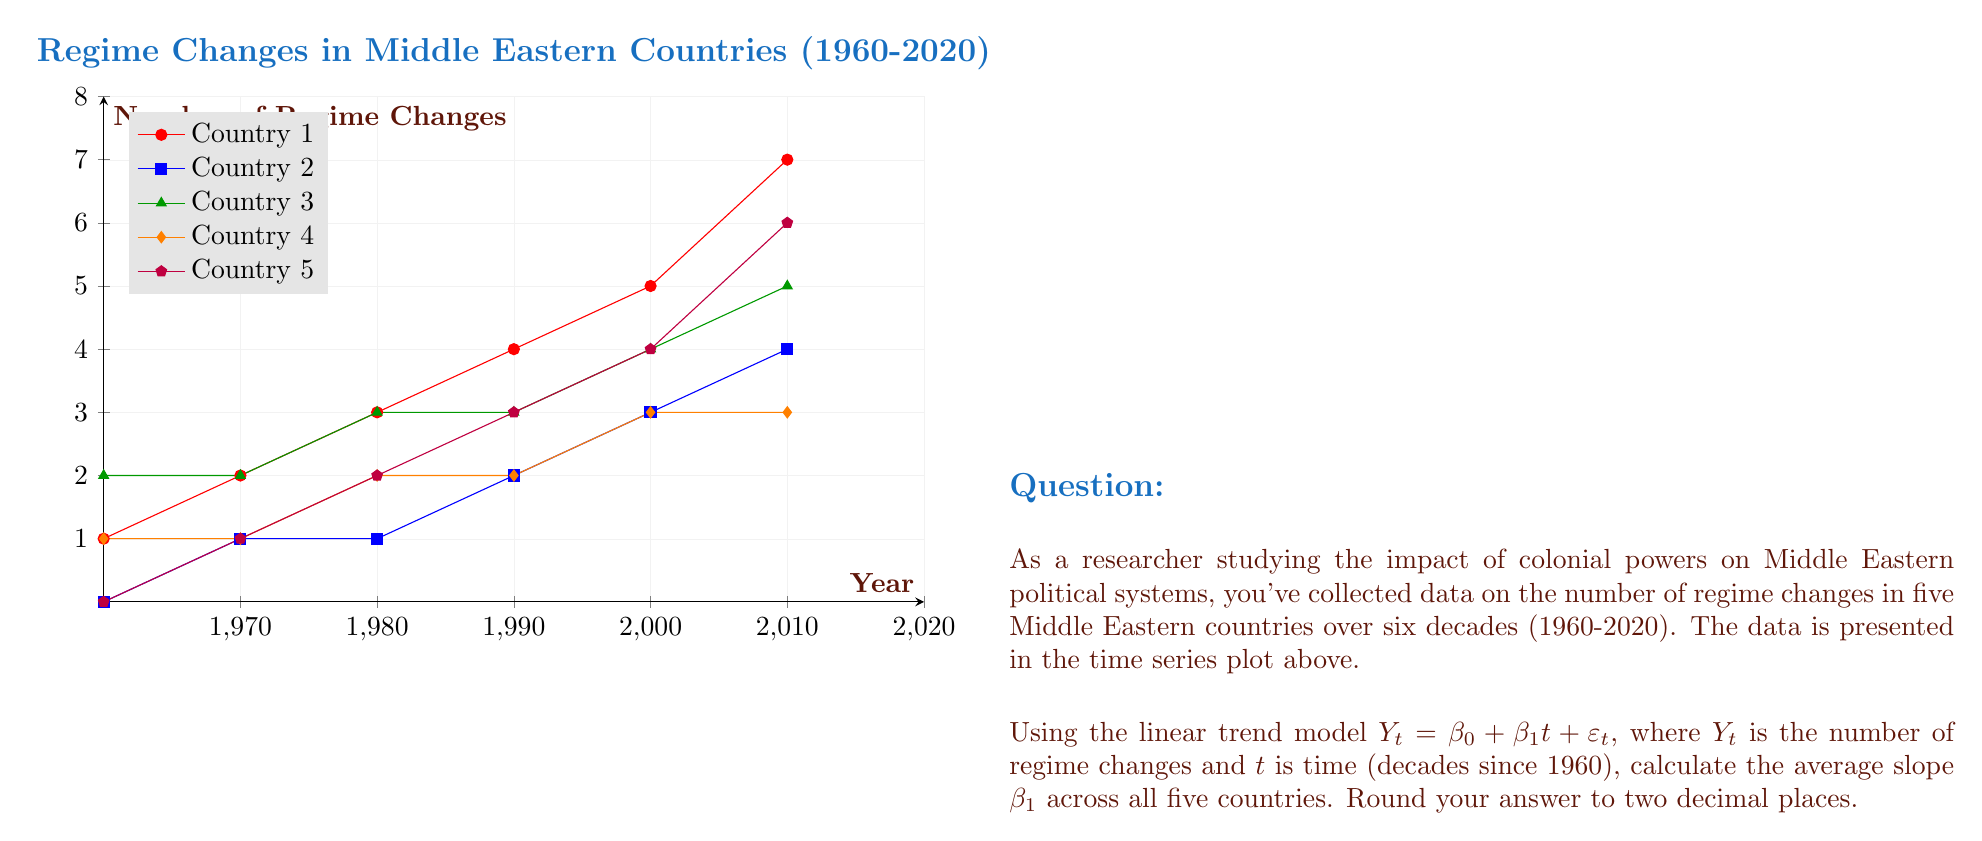Could you help me with this problem? To solve this problem, we need to calculate the slope $\beta_1$ for each country and then take their average. We can use the formula for the slope in a simple linear regression:

$$\beta_1 = \frac{n\sum{ty} - \sum{t}\sum{y}}{n\sum{t^2} - (\sum{t})^2}$$

Where $n$ is the number of data points, $t$ is the time variable, and $y$ is the number of regime changes.

For all countries, $n = 6$ and $t = 0, 1, 2, 3, 4, 5$ (representing decades from 1960 to 2020).

Step 1: Calculate $\sum{t}$ and $\sum{t^2}$
$\sum{t} = 0 + 1 + 2 + 3 + 4 + 5 = 15$
$\sum{t^2} = 0^2 + 1^2 + 2^2 + 3^2 + 4^2 + 5^2 = 55$

Step 2: Calculate $\sum{y}$ and $\sum{ty}$ for each country

Country 1: $\sum{y} = 22$, $\sum{ty} = 70$
Country 2: $\sum{y} = 11$, $\sum{ty} = 39$
Country 3: $\sum{y} = 19$, $\sum{ty} = 57$
Country 4: $\sum{y} = 12$, $\sum{ty} = 36$
Country 5: $\sum{y} = 16$, $\sum{ty} = 58$

Step 3: Calculate $\beta_1$ for each country

Country 1: $\beta_1 = \frac{6(70) - 15(22)}{6(55) - 15^2} = \frac{90}{105} = 0.8571$
Country 2: $\beta_1 = \frac{6(39) - 15(11)}{6(55) - 15^2} = \frac{69}{105} = 0.6571$
Country 3: $\beta_1 = \frac{6(57) - 15(19)}{6(55) - 15^2} = \frac{57}{105} = 0.5429$
Country 4: $\beta_1 = \frac{6(36) - 15(12)}{6(55) - 15^2} = \frac{36}{105} = 0.3429$
Country 5: $\beta_1 = \frac{6(58) - 15(16)}{6(55) - 15^2} = \frac{78}{105} = 0.7429$

Step 4: Calculate the average slope

Average $\beta_1 = \frac{0.8571 + 0.6571 + 0.5429 + 0.3429 + 0.7429}{5} = 0.6286$

Step 5: Round to two decimal places

Final answer: 0.63
Answer: 0.63 